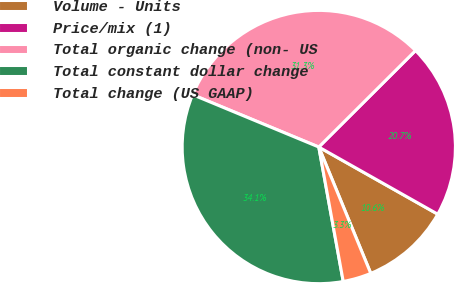<chart> <loc_0><loc_0><loc_500><loc_500><pie_chart><fcel>Volume - Units<fcel>Price/mix (1)<fcel>Total organic change (non- US<fcel>Total constant dollar change<fcel>Total change (US GAAP)<nl><fcel>10.61%<fcel>20.66%<fcel>31.27%<fcel>34.12%<fcel>3.35%<nl></chart> 